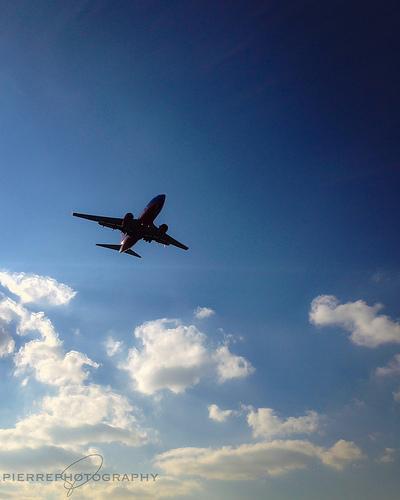How many airplanes are in the picture?
Give a very brief answer. 1. 